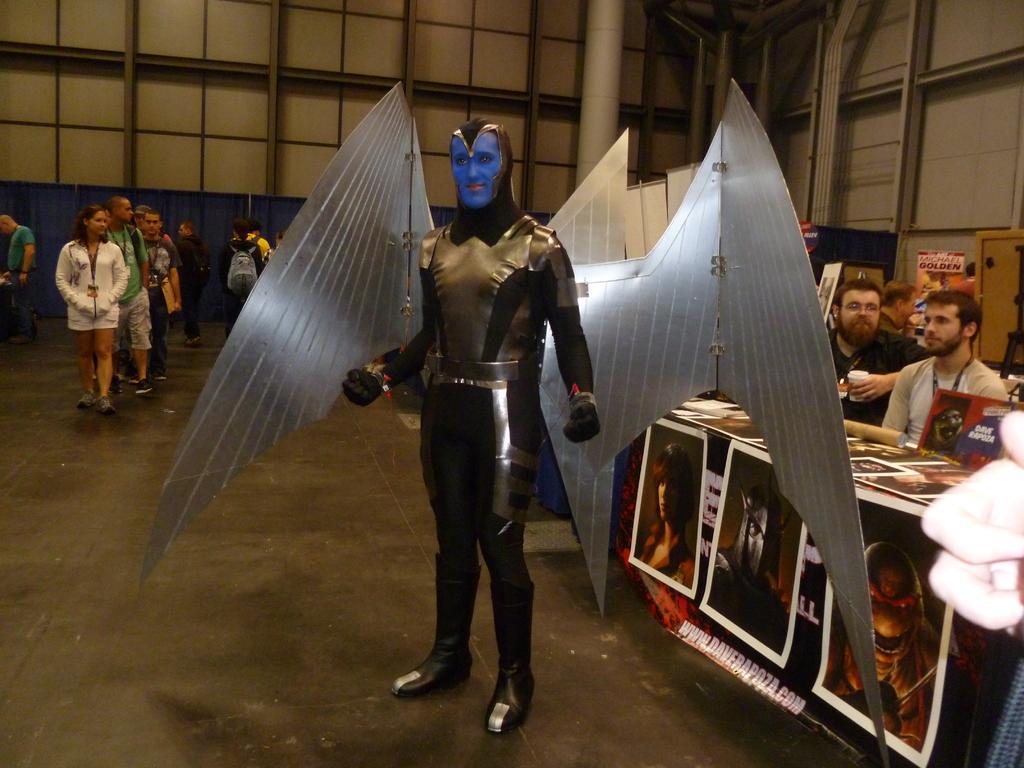In one or two sentences, can you explain what this image depicts? In this image I can see people where few are sitting and rest all are standing. Here I can see one person and I can see he is wearing costume. I can also see a table and I can see number of posters. 